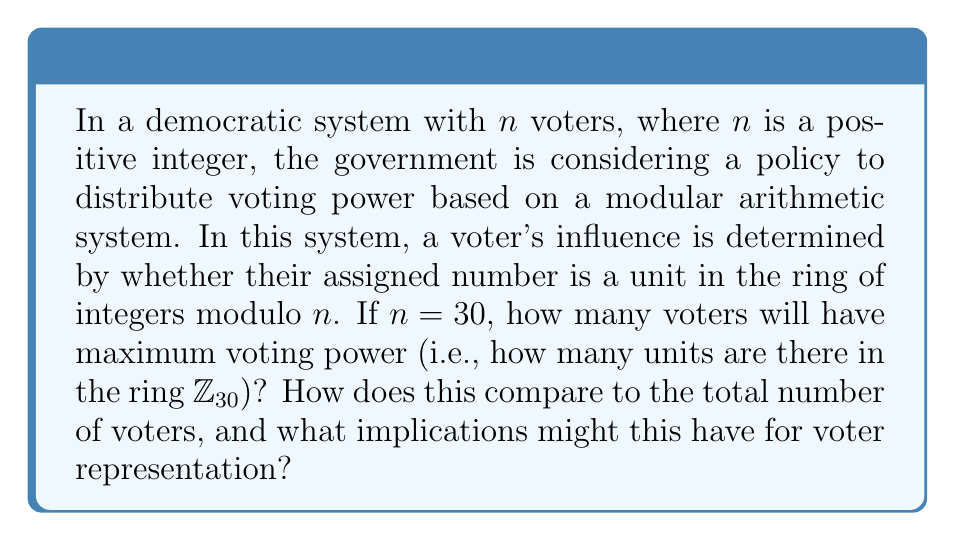What is the answer to this math problem? To solve this problem, we need to follow these steps:

1) First, recall that in the ring of integers modulo $n$, denoted as $\mathbb{Z}_n$, an element $a$ is a unit if and only if it has a multiplicative inverse. This occurs when $\gcd(a,n) = 1$.

2) For $\mathbb{Z}_{30}$, we need to count how many numbers from 1 to 29 are coprime to 30.

3) To find this, let's factor 30:
   $30 = 2 \times 3 \times 5$

4) The numbers that are not coprime to 30 are those divisible by 2, 3, or 5. We can use the principle of inclusion-exclusion to count these:

   - Numbers divisible by 2: 15
   - Numbers divisible by 3: 10
   - Numbers divisible by 5: 6
   - Numbers divisible by 2 and 3: 5
   - Numbers divisible by 2 and 5: 3
   - Numbers divisible by 3 and 5: 2
   - Numbers divisible by 2, 3, and 5: 1

5) Total non-coprime numbers = 15 + 10 + 6 - 5 - 3 - 2 + 1 = 22

6) Therefore, the number of coprime numbers (units) = 30 - 22 = 8

7) The 8 units in $\mathbb{Z}_{30}$ are: 1, 7, 11, 13, 17, 19, 23, 29

8) Comparison to total voters: 8 out of 30, or about 26.67%

Implications for voter representation:
- Only about a quarter of voters would have maximum voting power.
- This could lead to concerns about equity in voting influence.
- It might encourage the formation of voting blocs or coalitions among those with less voting power.
- The policy might need to be adjusted to ensure fair representation for all voters.
Answer: There are 8 units in the ring $\mathbb{Z}_{30}$, representing 26.67% of the total voters. 